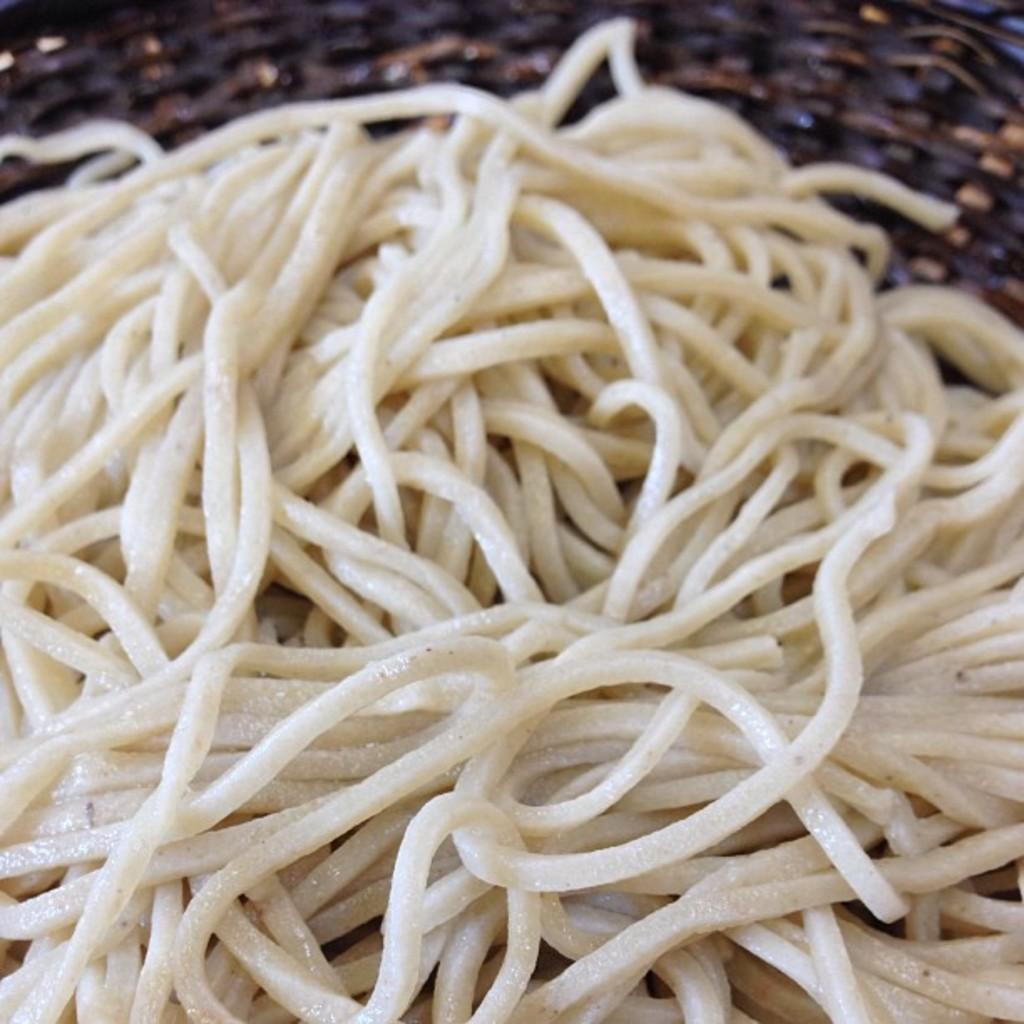What type of food is visible in the front of the image? There are noodles in the front of the image. What object can be seen in the background of the image? There appears to be a basket in the background of the image. What type of chess pieces are present on the table in the image? There is no chess set or any chess pieces present in the image. What type of educational materials can be seen in the image? There are no educational materials visible in the image. 